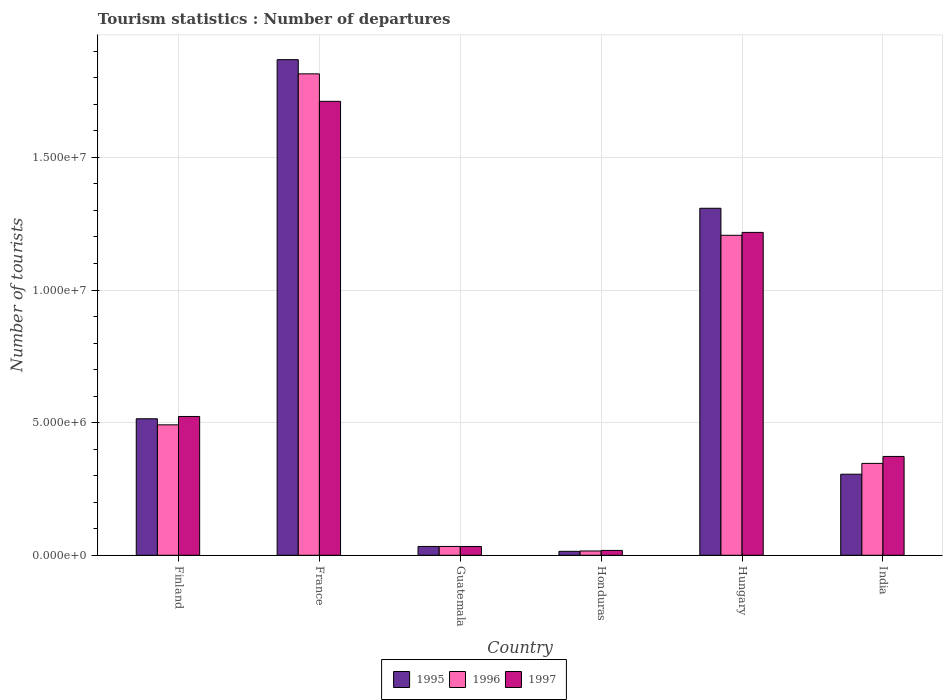Are the number of bars on each tick of the X-axis equal?
Your answer should be very brief. Yes. How many bars are there on the 6th tick from the left?
Give a very brief answer. 3. How many bars are there on the 3rd tick from the right?
Provide a short and direct response. 3. What is the label of the 6th group of bars from the left?
Keep it short and to the point. India. What is the number of tourist departures in 1996 in Honduras?
Your answer should be compact. 1.62e+05. Across all countries, what is the maximum number of tourist departures in 1996?
Keep it short and to the point. 1.82e+07. Across all countries, what is the minimum number of tourist departures in 1996?
Offer a terse response. 1.62e+05. In which country was the number of tourist departures in 1995 minimum?
Provide a short and direct response. Honduras. What is the total number of tourist departures in 1996 in the graph?
Offer a very short reply. 3.91e+07. What is the difference between the number of tourist departures in 1997 in Hungary and that in India?
Provide a succinct answer. 8.45e+06. What is the difference between the number of tourist departures in 1997 in Hungary and the number of tourist departures in 1996 in Finland?
Keep it short and to the point. 7.26e+06. What is the average number of tourist departures in 1997 per country?
Ensure brevity in your answer.  6.46e+06. What is the difference between the number of tourist departures of/in 1996 and number of tourist departures of/in 1997 in Honduras?
Your answer should be compact. -2.10e+04. What is the ratio of the number of tourist departures in 1996 in Finland to that in Honduras?
Your answer should be very brief. 30.36. Is the difference between the number of tourist departures in 1996 in Honduras and India greater than the difference between the number of tourist departures in 1997 in Honduras and India?
Make the answer very short. Yes. What is the difference between the highest and the second highest number of tourist departures in 1995?
Your response must be concise. 5.60e+06. What is the difference between the highest and the lowest number of tourist departures in 1996?
Give a very brief answer. 1.80e+07. Is the sum of the number of tourist departures in 1995 in Finland and France greater than the maximum number of tourist departures in 1997 across all countries?
Offer a very short reply. Yes. What does the 2nd bar from the left in India represents?
Keep it short and to the point. 1996. What does the 1st bar from the right in India represents?
Provide a succinct answer. 1997. How many bars are there?
Ensure brevity in your answer.  18. Are all the bars in the graph horizontal?
Offer a very short reply. No. Are the values on the major ticks of Y-axis written in scientific E-notation?
Provide a succinct answer. Yes. Does the graph contain any zero values?
Make the answer very short. No. Does the graph contain grids?
Offer a terse response. Yes. How many legend labels are there?
Offer a terse response. 3. What is the title of the graph?
Offer a very short reply. Tourism statistics : Number of departures. What is the label or title of the Y-axis?
Provide a short and direct response. Number of tourists. What is the Number of tourists in 1995 in Finland?
Provide a succinct answer. 5.15e+06. What is the Number of tourists of 1996 in Finland?
Give a very brief answer. 4.92e+06. What is the Number of tourists of 1997 in Finland?
Give a very brief answer. 5.23e+06. What is the Number of tourists in 1995 in France?
Make the answer very short. 1.87e+07. What is the Number of tourists in 1996 in France?
Your response must be concise. 1.82e+07. What is the Number of tourists of 1997 in France?
Give a very brief answer. 1.71e+07. What is the Number of tourists of 1995 in Guatemala?
Provide a short and direct response. 3.33e+05. What is the Number of tourists of 1996 in Guatemala?
Your answer should be compact. 3.33e+05. What is the Number of tourists in 1997 in Guatemala?
Keep it short and to the point. 3.31e+05. What is the Number of tourists of 1995 in Honduras?
Your answer should be very brief. 1.49e+05. What is the Number of tourists of 1996 in Honduras?
Keep it short and to the point. 1.62e+05. What is the Number of tourists of 1997 in Honduras?
Your answer should be very brief. 1.83e+05. What is the Number of tourists of 1995 in Hungary?
Your answer should be compact. 1.31e+07. What is the Number of tourists in 1996 in Hungary?
Make the answer very short. 1.21e+07. What is the Number of tourists in 1997 in Hungary?
Your answer should be compact. 1.22e+07. What is the Number of tourists in 1995 in India?
Give a very brief answer. 3.06e+06. What is the Number of tourists in 1996 in India?
Ensure brevity in your answer.  3.46e+06. What is the Number of tourists of 1997 in India?
Offer a terse response. 3.73e+06. Across all countries, what is the maximum Number of tourists in 1995?
Your answer should be compact. 1.87e+07. Across all countries, what is the maximum Number of tourists of 1996?
Provide a short and direct response. 1.82e+07. Across all countries, what is the maximum Number of tourists in 1997?
Ensure brevity in your answer.  1.71e+07. Across all countries, what is the minimum Number of tourists of 1995?
Your answer should be very brief. 1.49e+05. Across all countries, what is the minimum Number of tourists of 1996?
Your response must be concise. 1.62e+05. Across all countries, what is the minimum Number of tourists in 1997?
Provide a succinct answer. 1.83e+05. What is the total Number of tourists of 1995 in the graph?
Offer a very short reply. 4.05e+07. What is the total Number of tourists of 1996 in the graph?
Offer a very short reply. 3.91e+07. What is the total Number of tourists in 1997 in the graph?
Make the answer very short. 3.88e+07. What is the difference between the Number of tourists in 1995 in Finland and that in France?
Your answer should be very brief. -1.35e+07. What is the difference between the Number of tourists of 1996 in Finland and that in France?
Ensure brevity in your answer.  -1.32e+07. What is the difference between the Number of tourists in 1997 in Finland and that in France?
Offer a very short reply. -1.19e+07. What is the difference between the Number of tourists in 1995 in Finland and that in Guatemala?
Provide a short and direct response. 4.81e+06. What is the difference between the Number of tourists of 1996 in Finland and that in Guatemala?
Ensure brevity in your answer.  4.58e+06. What is the difference between the Number of tourists of 1997 in Finland and that in Guatemala?
Keep it short and to the point. 4.90e+06. What is the difference between the Number of tourists of 1995 in Finland and that in Honduras?
Provide a succinct answer. 5.00e+06. What is the difference between the Number of tourists in 1996 in Finland and that in Honduras?
Provide a short and direct response. 4.76e+06. What is the difference between the Number of tourists in 1997 in Finland and that in Honduras?
Your answer should be very brief. 5.05e+06. What is the difference between the Number of tourists of 1995 in Finland and that in Hungary?
Offer a terse response. -7.94e+06. What is the difference between the Number of tourists of 1996 in Finland and that in Hungary?
Give a very brief answer. -7.15e+06. What is the difference between the Number of tourists of 1997 in Finland and that in Hungary?
Offer a terse response. -6.94e+06. What is the difference between the Number of tourists in 1995 in Finland and that in India?
Ensure brevity in your answer.  2.09e+06. What is the difference between the Number of tourists of 1996 in Finland and that in India?
Offer a terse response. 1.45e+06. What is the difference between the Number of tourists in 1997 in Finland and that in India?
Provide a short and direct response. 1.51e+06. What is the difference between the Number of tourists of 1995 in France and that in Guatemala?
Your response must be concise. 1.84e+07. What is the difference between the Number of tourists in 1996 in France and that in Guatemala?
Give a very brief answer. 1.78e+07. What is the difference between the Number of tourists of 1997 in France and that in Guatemala?
Your answer should be very brief. 1.68e+07. What is the difference between the Number of tourists of 1995 in France and that in Honduras?
Provide a succinct answer. 1.85e+07. What is the difference between the Number of tourists in 1996 in France and that in Honduras?
Your response must be concise. 1.80e+07. What is the difference between the Number of tourists in 1997 in France and that in Honduras?
Give a very brief answer. 1.69e+07. What is the difference between the Number of tourists in 1995 in France and that in Hungary?
Your answer should be compact. 5.60e+06. What is the difference between the Number of tourists of 1996 in France and that in Hungary?
Make the answer very short. 6.09e+06. What is the difference between the Number of tourists of 1997 in France and that in Hungary?
Keep it short and to the point. 4.94e+06. What is the difference between the Number of tourists in 1995 in France and that in India?
Your answer should be compact. 1.56e+07. What is the difference between the Number of tourists in 1996 in France and that in India?
Offer a terse response. 1.47e+07. What is the difference between the Number of tourists of 1997 in France and that in India?
Provide a short and direct response. 1.34e+07. What is the difference between the Number of tourists in 1995 in Guatemala and that in Honduras?
Provide a succinct answer. 1.84e+05. What is the difference between the Number of tourists in 1996 in Guatemala and that in Honduras?
Your response must be concise. 1.71e+05. What is the difference between the Number of tourists in 1997 in Guatemala and that in Honduras?
Your answer should be compact. 1.48e+05. What is the difference between the Number of tourists in 1995 in Guatemala and that in Hungary?
Your answer should be very brief. -1.28e+07. What is the difference between the Number of tourists in 1996 in Guatemala and that in Hungary?
Offer a terse response. -1.17e+07. What is the difference between the Number of tourists of 1997 in Guatemala and that in Hungary?
Your answer should be compact. -1.18e+07. What is the difference between the Number of tourists of 1995 in Guatemala and that in India?
Offer a terse response. -2.72e+06. What is the difference between the Number of tourists in 1996 in Guatemala and that in India?
Your response must be concise. -3.13e+06. What is the difference between the Number of tourists of 1997 in Guatemala and that in India?
Provide a short and direct response. -3.40e+06. What is the difference between the Number of tourists of 1995 in Honduras and that in Hungary?
Provide a short and direct response. -1.29e+07. What is the difference between the Number of tourists in 1996 in Honduras and that in Hungary?
Offer a terse response. -1.19e+07. What is the difference between the Number of tourists of 1997 in Honduras and that in Hungary?
Give a very brief answer. -1.20e+07. What is the difference between the Number of tourists in 1995 in Honduras and that in India?
Make the answer very short. -2.91e+06. What is the difference between the Number of tourists of 1996 in Honduras and that in India?
Provide a short and direct response. -3.30e+06. What is the difference between the Number of tourists in 1997 in Honduras and that in India?
Your response must be concise. -3.54e+06. What is the difference between the Number of tourists of 1995 in Hungary and that in India?
Offer a very short reply. 1.00e+07. What is the difference between the Number of tourists in 1996 in Hungary and that in India?
Provide a succinct answer. 8.60e+06. What is the difference between the Number of tourists in 1997 in Hungary and that in India?
Your answer should be very brief. 8.45e+06. What is the difference between the Number of tourists in 1995 in Finland and the Number of tourists in 1996 in France?
Keep it short and to the point. -1.30e+07. What is the difference between the Number of tourists of 1995 in Finland and the Number of tourists of 1997 in France?
Ensure brevity in your answer.  -1.20e+07. What is the difference between the Number of tourists of 1996 in Finland and the Number of tourists of 1997 in France?
Offer a terse response. -1.22e+07. What is the difference between the Number of tourists in 1995 in Finland and the Number of tourists in 1996 in Guatemala?
Keep it short and to the point. 4.81e+06. What is the difference between the Number of tourists of 1995 in Finland and the Number of tourists of 1997 in Guatemala?
Ensure brevity in your answer.  4.82e+06. What is the difference between the Number of tourists in 1996 in Finland and the Number of tourists in 1997 in Guatemala?
Offer a terse response. 4.59e+06. What is the difference between the Number of tourists of 1995 in Finland and the Number of tourists of 1996 in Honduras?
Your answer should be very brief. 4.98e+06. What is the difference between the Number of tourists in 1995 in Finland and the Number of tourists in 1997 in Honduras?
Your response must be concise. 4.96e+06. What is the difference between the Number of tourists of 1996 in Finland and the Number of tourists of 1997 in Honduras?
Provide a succinct answer. 4.74e+06. What is the difference between the Number of tourists of 1995 in Finland and the Number of tourists of 1996 in Hungary?
Ensure brevity in your answer.  -6.92e+06. What is the difference between the Number of tourists in 1995 in Finland and the Number of tourists in 1997 in Hungary?
Give a very brief answer. -7.03e+06. What is the difference between the Number of tourists of 1996 in Finland and the Number of tourists of 1997 in Hungary?
Provide a short and direct response. -7.26e+06. What is the difference between the Number of tourists in 1995 in Finland and the Number of tourists in 1996 in India?
Your response must be concise. 1.68e+06. What is the difference between the Number of tourists of 1995 in Finland and the Number of tourists of 1997 in India?
Offer a terse response. 1.42e+06. What is the difference between the Number of tourists of 1996 in Finland and the Number of tourists of 1997 in India?
Give a very brief answer. 1.19e+06. What is the difference between the Number of tourists of 1995 in France and the Number of tourists of 1996 in Guatemala?
Ensure brevity in your answer.  1.84e+07. What is the difference between the Number of tourists in 1995 in France and the Number of tourists in 1997 in Guatemala?
Provide a succinct answer. 1.84e+07. What is the difference between the Number of tourists of 1996 in France and the Number of tourists of 1997 in Guatemala?
Your response must be concise. 1.78e+07. What is the difference between the Number of tourists of 1995 in France and the Number of tourists of 1996 in Honduras?
Keep it short and to the point. 1.85e+07. What is the difference between the Number of tourists of 1995 in France and the Number of tourists of 1997 in Honduras?
Keep it short and to the point. 1.85e+07. What is the difference between the Number of tourists of 1996 in France and the Number of tourists of 1997 in Honduras?
Your answer should be very brief. 1.80e+07. What is the difference between the Number of tourists in 1995 in France and the Number of tourists in 1996 in Hungary?
Keep it short and to the point. 6.62e+06. What is the difference between the Number of tourists of 1995 in France and the Number of tourists of 1997 in Hungary?
Make the answer very short. 6.51e+06. What is the difference between the Number of tourists of 1996 in France and the Number of tourists of 1997 in Hungary?
Your answer should be compact. 5.98e+06. What is the difference between the Number of tourists in 1995 in France and the Number of tourists in 1996 in India?
Provide a short and direct response. 1.52e+07. What is the difference between the Number of tourists in 1995 in France and the Number of tourists in 1997 in India?
Provide a succinct answer. 1.50e+07. What is the difference between the Number of tourists of 1996 in France and the Number of tourists of 1997 in India?
Ensure brevity in your answer.  1.44e+07. What is the difference between the Number of tourists in 1995 in Guatemala and the Number of tourists in 1996 in Honduras?
Give a very brief answer. 1.71e+05. What is the difference between the Number of tourists in 1995 in Guatemala and the Number of tourists in 1996 in Hungary?
Ensure brevity in your answer.  -1.17e+07. What is the difference between the Number of tourists in 1995 in Guatemala and the Number of tourists in 1997 in Hungary?
Give a very brief answer. -1.18e+07. What is the difference between the Number of tourists in 1996 in Guatemala and the Number of tourists in 1997 in Hungary?
Your response must be concise. -1.18e+07. What is the difference between the Number of tourists in 1995 in Guatemala and the Number of tourists in 1996 in India?
Your answer should be very brief. -3.13e+06. What is the difference between the Number of tourists in 1995 in Guatemala and the Number of tourists in 1997 in India?
Offer a very short reply. -3.39e+06. What is the difference between the Number of tourists in 1996 in Guatemala and the Number of tourists in 1997 in India?
Keep it short and to the point. -3.39e+06. What is the difference between the Number of tourists in 1995 in Honduras and the Number of tourists in 1996 in Hungary?
Offer a terse response. -1.19e+07. What is the difference between the Number of tourists of 1995 in Honduras and the Number of tourists of 1997 in Hungary?
Your answer should be very brief. -1.20e+07. What is the difference between the Number of tourists in 1996 in Honduras and the Number of tourists in 1997 in Hungary?
Ensure brevity in your answer.  -1.20e+07. What is the difference between the Number of tourists of 1995 in Honduras and the Number of tourists of 1996 in India?
Offer a terse response. -3.32e+06. What is the difference between the Number of tourists of 1995 in Honduras and the Number of tourists of 1997 in India?
Provide a succinct answer. -3.58e+06. What is the difference between the Number of tourists of 1996 in Honduras and the Number of tourists of 1997 in India?
Your response must be concise. -3.56e+06. What is the difference between the Number of tourists of 1995 in Hungary and the Number of tourists of 1996 in India?
Keep it short and to the point. 9.62e+06. What is the difference between the Number of tourists of 1995 in Hungary and the Number of tourists of 1997 in India?
Your response must be concise. 9.36e+06. What is the difference between the Number of tourists of 1996 in Hungary and the Number of tourists of 1997 in India?
Offer a very short reply. 8.34e+06. What is the average Number of tourists of 1995 per country?
Offer a very short reply. 6.74e+06. What is the average Number of tourists in 1996 per country?
Offer a very short reply. 6.52e+06. What is the average Number of tourists of 1997 per country?
Keep it short and to the point. 6.46e+06. What is the difference between the Number of tourists of 1995 and Number of tourists of 1996 in Finland?
Provide a succinct answer. 2.29e+05. What is the difference between the Number of tourists of 1995 and Number of tourists of 1997 in Finland?
Your answer should be compact. -8.60e+04. What is the difference between the Number of tourists of 1996 and Number of tourists of 1997 in Finland?
Make the answer very short. -3.15e+05. What is the difference between the Number of tourists in 1995 and Number of tourists in 1996 in France?
Offer a terse response. 5.35e+05. What is the difference between the Number of tourists in 1995 and Number of tourists in 1997 in France?
Your answer should be very brief. 1.57e+06. What is the difference between the Number of tourists in 1996 and Number of tourists in 1997 in France?
Offer a very short reply. 1.04e+06. What is the difference between the Number of tourists in 1995 and Number of tourists in 1996 in Honduras?
Make the answer very short. -1.30e+04. What is the difference between the Number of tourists of 1995 and Number of tourists of 1997 in Honduras?
Keep it short and to the point. -3.40e+04. What is the difference between the Number of tourists in 1996 and Number of tourists in 1997 in Honduras?
Make the answer very short. -2.10e+04. What is the difference between the Number of tourists of 1995 and Number of tourists of 1996 in Hungary?
Make the answer very short. 1.02e+06. What is the difference between the Number of tourists of 1995 and Number of tourists of 1997 in Hungary?
Provide a succinct answer. 9.10e+05. What is the difference between the Number of tourists of 1996 and Number of tourists of 1997 in Hungary?
Make the answer very short. -1.09e+05. What is the difference between the Number of tourists of 1995 and Number of tourists of 1996 in India?
Give a very brief answer. -4.08e+05. What is the difference between the Number of tourists of 1995 and Number of tourists of 1997 in India?
Your response must be concise. -6.70e+05. What is the difference between the Number of tourists in 1996 and Number of tourists in 1997 in India?
Keep it short and to the point. -2.62e+05. What is the ratio of the Number of tourists in 1995 in Finland to that in France?
Your answer should be compact. 0.28. What is the ratio of the Number of tourists of 1996 in Finland to that in France?
Ensure brevity in your answer.  0.27. What is the ratio of the Number of tourists in 1997 in Finland to that in France?
Your answer should be compact. 0.31. What is the ratio of the Number of tourists in 1995 in Finland to that in Guatemala?
Your answer should be compact. 15.46. What is the ratio of the Number of tourists in 1996 in Finland to that in Guatemala?
Give a very brief answer. 14.77. What is the ratio of the Number of tourists in 1997 in Finland to that in Guatemala?
Your answer should be very brief. 15.81. What is the ratio of the Number of tourists of 1995 in Finland to that in Honduras?
Give a very brief answer. 34.54. What is the ratio of the Number of tourists of 1996 in Finland to that in Honduras?
Your answer should be compact. 30.36. What is the ratio of the Number of tourists in 1997 in Finland to that in Honduras?
Keep it short and to the point. 28.6. What is the ratio of the Number of tourists of 1995 in Finland to that in Hungary?
Your answer should be very brief. 0.39. What is the ratio of the Number of tourists in 1996 in Finland to that in Hungary?
Your answer should be very brief. 0.41. What is the ratio of the Number of tourists in 1997 in Finland to that in Hungary?
Keep it short and to the point. 0.43. What is the ratio of the Number of tourists in 1995 in Finland to that in India?
Keep it short and to the point. 1.68. What is the ratio of the Number of tourists of 1996 in Finland to that in India?
Make the answer very short. 1.42. What is the ratio of the Number of tourists of 1997 in Finland to that in India?
Provide a short and direct response. 1.4. What is the ratio of the Number of tourists in 1995 in France to that in Guatemala?
Offer a very short reply. 56.11. What is the ratio of the Number of tourists in 1996 in France to that in Guatemala?
Provide a succinct answer. 54.51. What is the ratio of the Number of tourists in 1997 in France to that in Guatemala?
Provide a short and direct response. 51.71. What is the ratio of the Number of tourists of 1995 in France to that in Honduras?
Offer a terse response. 125.41. What is the ratio of the Number of tourists of 1996 in France to that in Honduras?
Make the answer very short. 112.04. What is the ratio of the Number of tourists of 1997 in France to that in Honduras?
Keep it short and to the point. 93.52. What is the ratio of the Number of tourists of 1995 in France to that in Hungary?
Provide a succinct answer. 1.43. What is the ratio of the Number of tourists of 1996 in France to that in Hungary?
Provide a short and direct response. 1.5. What is the ratio of the Number of tourists of 1997 in France to that in Hungary?
Ensure brevity in your answer.  1.41. What is the ratio of the Number of tourists of 1995 in France to that in India?
Your answer should be compact. 6.11. What is the ratio of the Number of tourists of 1996 in France to that in India?
Provide a short and direct response. 5.24. What is the ratio of the Number of tourists in 1997 in France to that in India?
Make the answer very short. 4.59. What is the ratio of the Number of tourists of 1995 in Guatemala to that in Honduras?
Make the answer very short. 2.23. What is the ratio of the Number of tourists in 1996 in Guatemala to that in Honduras?
Your response must be concise. 2.06. What is the ratio of the Number of tourists of 1997 in Guatemala to that in Honduras?
Provide a succinct answer. 1.81. What is the ratio of the Number of tourists of 1995 in Guatemala to that in Hungary?
Make the answer very short. 0.03. What is the ratio of the Number of tourists in 1996 in Guatemala to that in Hungary?
Provide a short and direct response. 0.03. What is the ratio of the Number of tourists in 1997 in Guatemala to that in Hungary?
Your answer should be very brief. 0.03. What is the ratio of the Number of tourists of 1995 in Guatemala to that in India?
Provide a succinct answer. 0.11. What is the ratio of the Number of tourists of 1996 in Guatemala to that in India?
Ensure brevity in your answer.  0.1. What is the ratio of the Number of tourists in 1997 in Guatemala to that in India?
Give a very brief answer. 0.09. What is the ratio of the Number of tourists of 1995 in Honduras to that in Hungary?
Ensure brevity in your answer.  0.01. What is the ratio of the Number of tourists of 1996 in Honduras to that in Hungary?
Provide a succinct answer. 0.01. What is the ratio of the Number of tourists in 1997 in Honduras to that in Hungary?
Give a very brief answer. 0.01. What is the ratio of the Number of tourists in 1995 in Honduras to that in India?
Offer a very short reply. 0.05. What is the ratio of the Number of tourists of 1996 in Honduras to that in India?
Keep it short and to the point. 0.05. What is the ratio of the Number of tourists of 1997 in Honduras to that in India?
Your response must be concise. 0.05. What is the ratio of the Number of tourists of 1995 in Hungary to that in India?
Give a very brief answer. 4.28. What is the ratio of the Number of tourists in 1996 in Hungary to that in India?
Your answer should be very brief. 3.48. What is the ratio of the Number of tourists in 1997 in Hungary to that in India?
Offer a terse response. 3.27. What is the difference between the highest and the second highest Number of tourists in 1995?
Offer a terse response. 5.60e+06. What is the difference between the highest and the second highest Number of tourists in 1996?
Your answer should be very brief. 6.09e+06. What is the difference between the highest and the second highest Number of tourists in 1997?
Provide a short and direct response. 4.94e+06. What is the difference between the highest and the lowest Number of tourists of 1995?
Offer a terse response. 1.85e+07. What is the difference between the highest and the lowest Number of tourists in 1996?
Make the answer very short. 1.80e+07. What is the difference between the highest and the lowest Number of tourists in 1997?
Provide a short and direct response. 1.69e+07. 